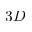Convert formula to latex. <formula><loc_0><loc_0><loc_500><loc_500>3 D</formula> 